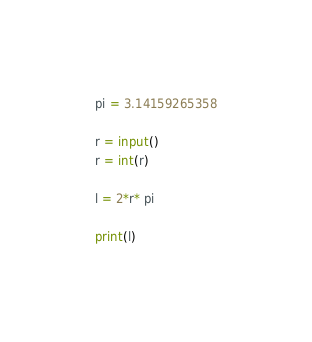Convert code to text. <code><loc_0><loc_0><loc_500><loc_500><_Python_>pi = 3.14159265358

r = input()
r = int(r)

l = 2*r* pi

print(l)</code> 